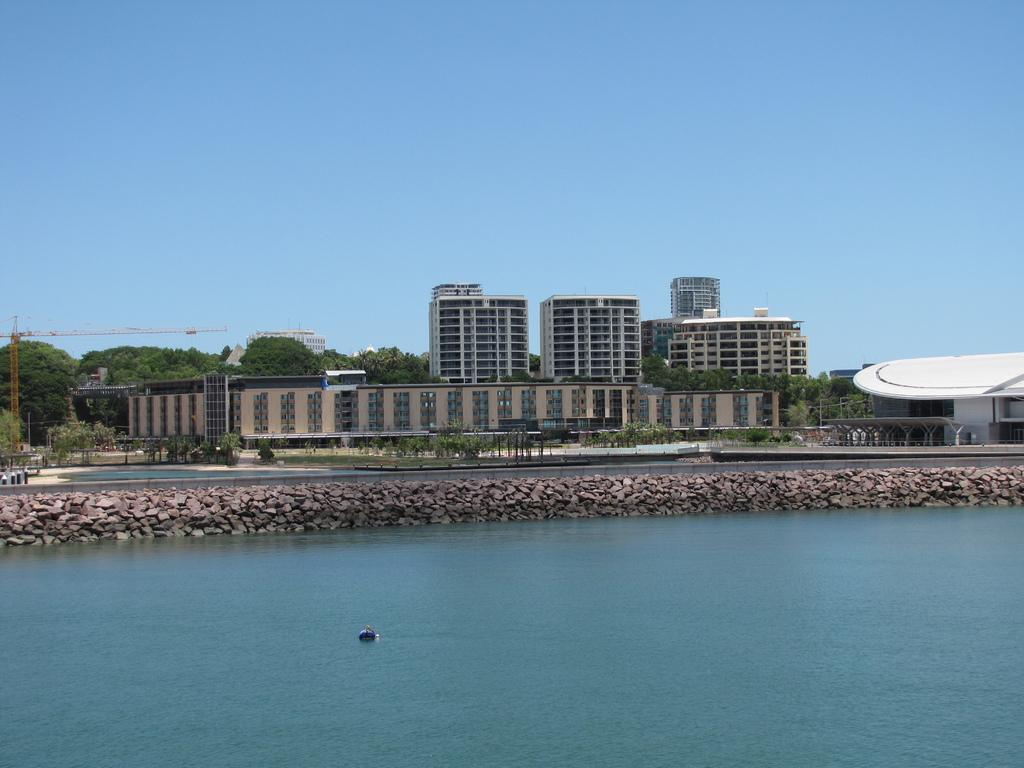What type of natural feature is present in the image? There is a river in the image. What structures are located near the river? There are buildings in front of the river. What large object can be seen on the left side of the image? There is a big crane on the left side of the image. What type of vegetation is present around the buildings? There are plenty of trees around the buildings. What type of honey can be seen dripping from the trees in the image? There is no honey present in the image; it features a river, buildings, a big crane, and trees. What type of iron is used to construct the buildings in the image? The type of iron used to construct the buildings cannot be determined from the image. 